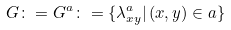<formula> <loc_0><loc_0><loc_500><loc_500>G \colon = G ^ { a } \colon = \{ \lambda ^ { a } _ { x y } | \, ( x , y ) \in a \}</formula> 